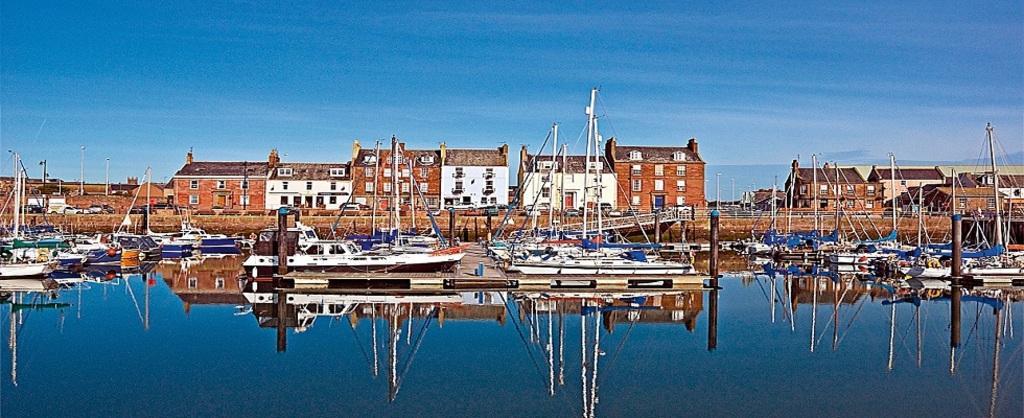Can you describe this image briefly? In this image we can see boats, poles, water, and buildings. In the background there is sky. On the water we can see the reflection. 